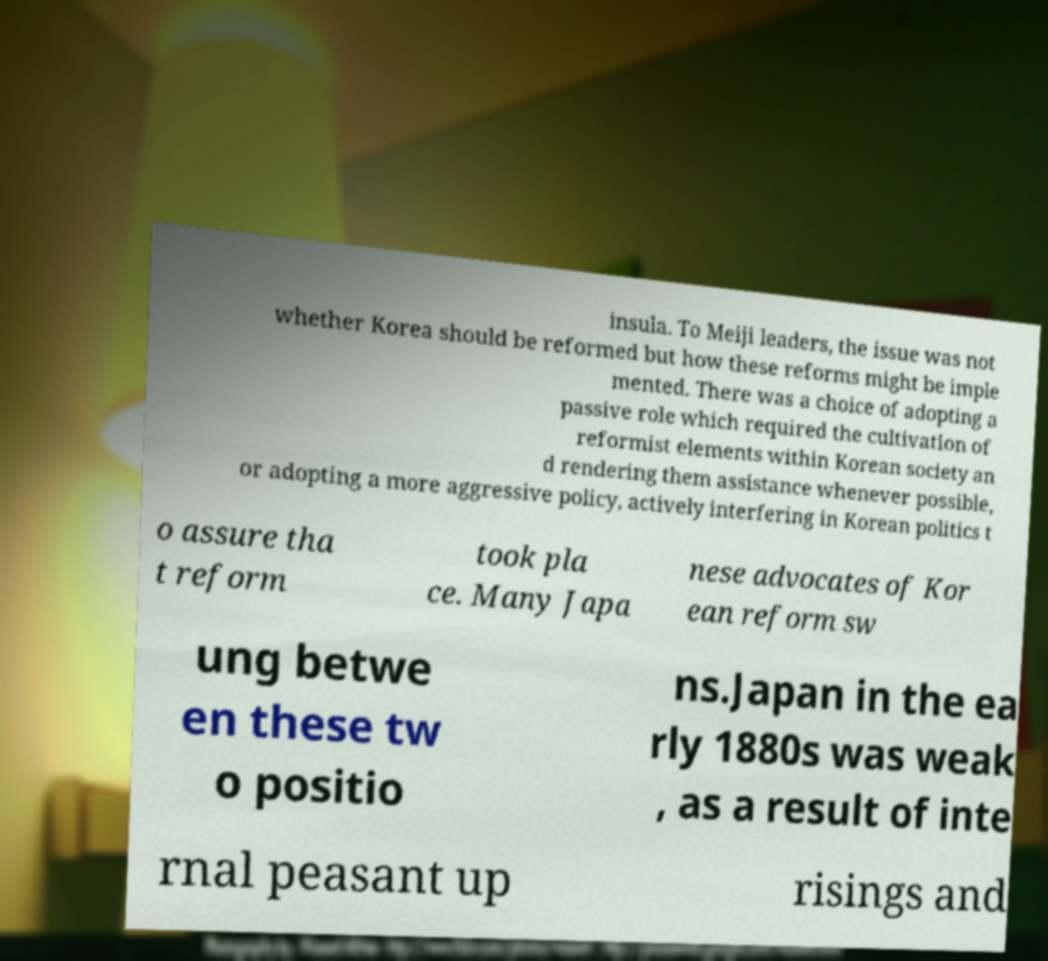Please identify and transcribe the text found in this image. insula. To Meiji leaders, the issue was not whether Korea should be reformed but how these reforms might be imple mented. There was a choice of adopting a passive role which required the cultivation of reformist elements within Korean society an d rendering them assistance whenever possible, or adopting a more aggressive policy, actively interfering in Korean politics t o assure tha t reform took pla ce. Many Japa nese advocates of Kor ean reform sw ung betwe en these tw o positio ns.Japan in the ea rly 1880s was weak , as a result of inte rnal peasant up risings and 